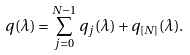<formula> <loc_0><loc_0><loc_500><loc_500>q ( \lambda ) = \sum _ { j = 0 } ^ { N - 1 } q _ { j } ( \lambda ) + q _ { [ N ] } ( \lambda ) .</formula> 